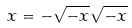<formula> <loc_0><loc_0><loc_500><loc_500>x = - \sqrt { - x } \sqrt { - x }</formula> 